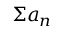<formula> <loc_0><loc_0><loc_500><loc_500>\Sigma a _ { n }</formula> 